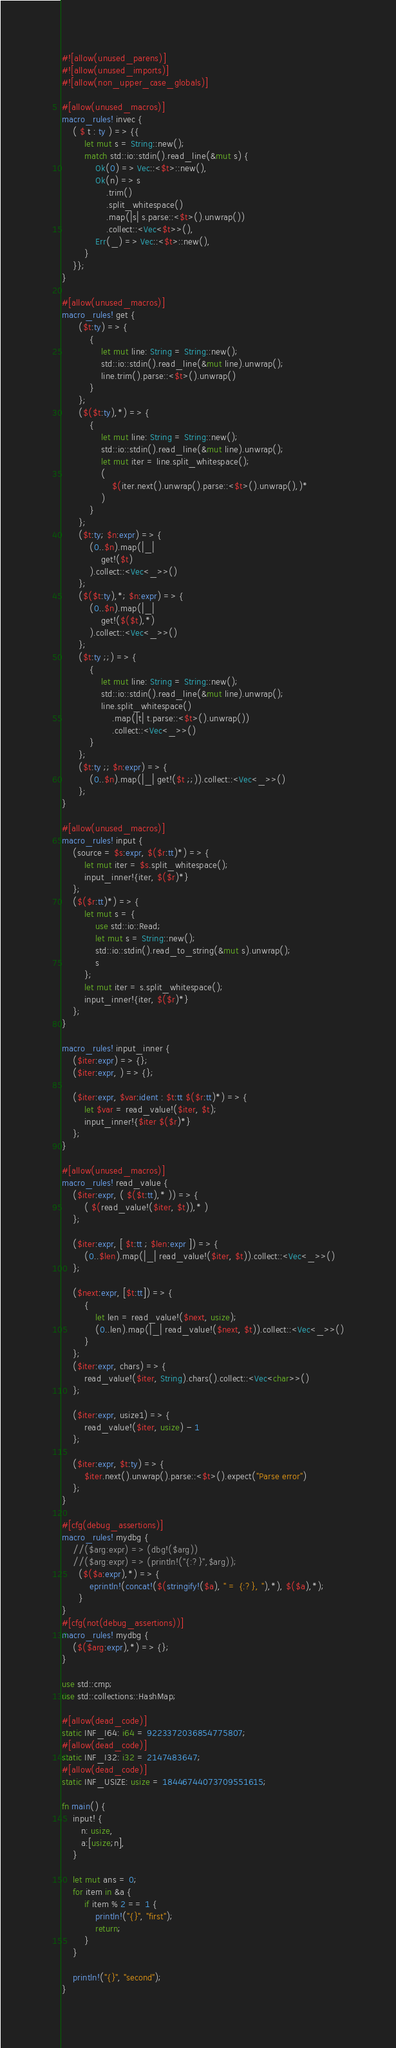<code> <loc_0><loc_0><loc_500><loc_500><_Rust_>#![allow(unused_parens)]
#![allow(unused_imports)]
#![allow(non_upper_case_globals)]

#[allow(unused_macros)]
macro_rules! invec {
    ( $ t : ty ) => {{
        let mut s = String::new();
        match std::io::stdin().read_line(&mut s) {
            Ok(0) => Vec::<$t>::new(),
            Ok(n) => s
                .trim()
                .split_whitespace()
                .map(|s| s.parse::<$t>().unwrap())
                .collect::<Vec<$t>>(),
            Err(_) => Vec::<$t>::new(),
        }
    }};
}

#[allow(unused_macros)]
macro_rules! get {
      ($t:ty) => {
          {
              let mut line: String = String::new();
              std::io::stdin().read_line(&mut line).unwrap();
              line.trim().parse::<$t>().unwrap()
          }
      };
      ($($t:ty),*) => {
          {
              let mut line: String = String::new();
              std::io::stdin().read_line(&mut line).unwrap();
              let mut iter = line.split_whitespace();
              (
                  $(iter.next().unwrap().parse::<$t>().unwrap(),)*
              )
          }
      };
      ($t:ty; $n:expr) => {
          (0..$n).map(|_|
              get!($t)
          ).collect::<Vec<_>>()
      };
      ($($t:ty),*; $n:expr) => {
          (0..$n).map(|_|
              get!($($t),*)
          ).collect::<Vec<_>>()
      };
      ($t:ty ;;) => {
          {
              let mut line: String = String::new();
              std::io::stdin().read_line(&mut line).unwrap();
              line.split_whitespace()
                  .map(|t| t.parse::<$t>().unwrap())
                  .collect::<Vec<_>>()
          }
      };
      ($t:ty ;; $n:expr) => {
          (0..$n).map(|_| get!($t ;;)).collect::<Vec<_>>()
      };
}

#[allow(unused_macros)]
macro_rules! input {
    (source = $s:expr, $($r:tt)*) => {
        let mut iter = $s.split_whitespace();
        input_inner!{iter, $($r)*}
    };
    ($($r:tt)*) => {
        let mut s = {
            use std::io::Read;
            let mut s = String::new();
            std::io::stdin().read_to_string(&mut s).unwrap();
            s
        };
        let mut iter = s.split_whitespace();
        input_inner!{iter, $($r)*}
    };
}

macro_rules! input_inner {
    ($iter:expr) => {};
    ($iter:expr, ) => {};

    ($iter:expr, $var:ident : $t:tt $($r:tt)*) => {
        let $var = read_value!($iter, $t);
        input_inner!{$iter $($r)*}
    };
}

#[allow(unused_macros)]
macro_rules! read_value {
    ($iter:expr, ( $($t:tt),* )) => {
        ( $(read_value!($iter, $t)),* )
    };

    ($iter:expr, [ $t:tt ; $len:expr ]) => {
        (0..$len).map(|_| read_value!($iter, $t)).collect::<Vec<_>>()
    };

    ($next:expr, [$t:tt]) => {
        {
            let len = read_value!($next, usize);
            (0..len).map(|_| read_value!($next, $t)).collect::<Vec<_>>()
        }
    };
    ($iter:expr, chars) => {
        read_value!($iter, String).chars().collect::<Vec<char>>()
    };

    ($iter:expr, usize1) => {
        read_value!($iter, usize) - 1
    };

    ($iter:expr, $t:ty) => {
        $iter.next().unwrap().parse::<$t>().expect("Parse error")
    };
}

#[cfg(debug_assertions)]
macro_rules! mydbg {
    //($arg:expr) => (dbg!($arg))
    //($arg:expr) => (println!("{:?}",$arg));
      ($($a:expr),*) => {
          eprintln!(concat!($(stringify!($a), " = {:?}, "),*), $($a),*);
      }
}
#[cfg(not(debug_assertions))]
macro_rules! mydbg {
    ($($arg:expr),*) => {};
}

use std::cmp;
use std::collections::HashMap;

#[allow(dead_code)]
static INF_I64: i64 = 9223372036854775807;
#[allow(dead_code)]
static INF_I32: i32 = 2147483647;
#[allow(dead_code)]
static INF_USIZE: usize = 18446744073709551615;

fn main() {
    input! {
       n: usize,
       a:[usize;n],
    }

    let mut ans = 0;
    for item in &a {
        if item % 2 == 1 {
            println!("{}", "first");
            return;
        }
    }

    println!("{}", "second");
}
</code> 